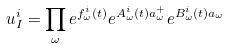Convert formula to latex. <formula><loc_0><loc_0><loc_500><loc_500>u _ { I } ^ { i } = \prod _ { \omega } e ^ { f _ { \omega } ^ { i } ( t ) } e ^ { A _ { \omega } ^ { i } ( t ) a _ { \omega } ^ { + } } e ^ { B _ { \omega } ^ { i } ( t ) a _ { \omega } }</formula> 